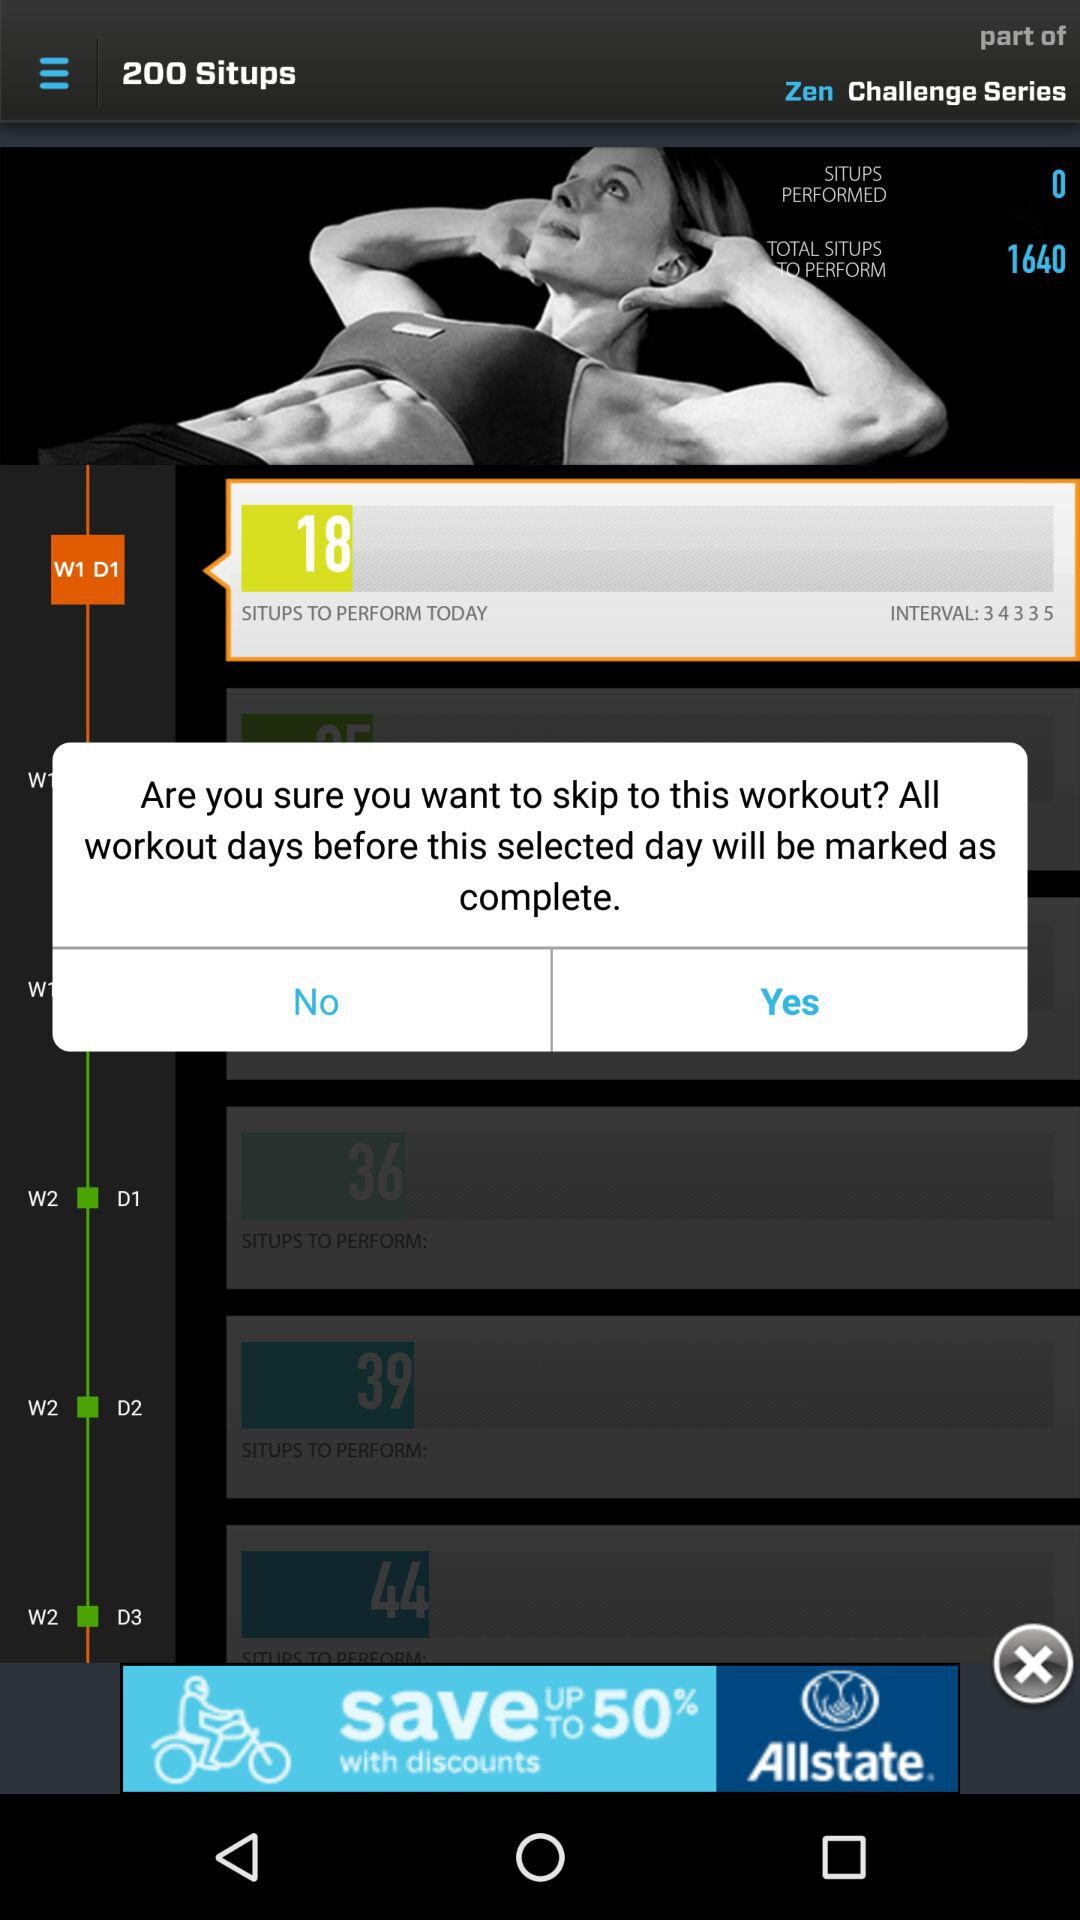What is the count of sit-ups on W2 D1? The count of sit-ups on W2 D1 is 36. 